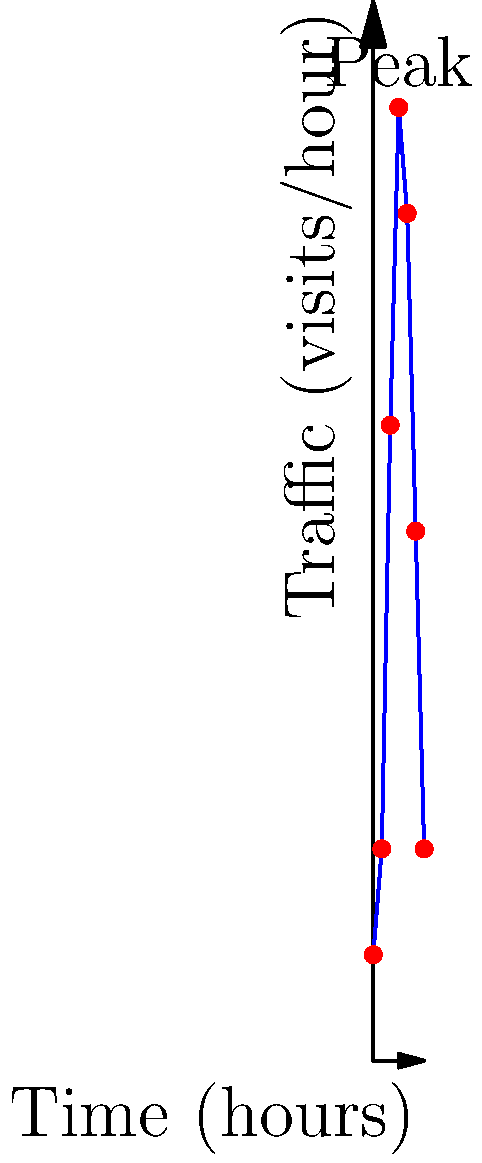As a web developer, you're analyzing your website's traffic data over a 24-hour period. The graph shows the number of visits per hour. If the area under the curve represents the total number of visits for the day, estimate the total daily traffic using the trapezoidal rule with 6 intervals. Round your answer to the nearest hundred. To estimate the area under the curve using the trapezoidal rule:

1. Divide the x-axis into 6 equal intervals of 4 hours each.
2. Use the formula: 
   $$A \approx \frac{h}{2}[f(x_0) + 2f(x_1) + 2f(x_2) + ... + 2f(x_{n-1}) + f(x_n)]$$
   where $h$ is the width of each interval, and $f(x_i)$ are the y-values.

3. In this case:
   $h = 4$ hours
   $f(x_0) = 50$, $f(x_1) = 100$, $f(x_2) = 300$, $f(x_3) = 450$, $f(x_4) = 400$, $f(x_5) = 250$, $f(x_6) = 100$

4. Applying the formula:
   $$A \approx \frac{4}{2}[50 + 2(100) + 2(300) + 2(450) + 2(400) + 2(250) + 100]$$
   $$A \approx 2[50 + 200 + 600 + 900 + 800 + 500 + 100]$$
   $$A \approx 2[3150]$$
   $$A \approx 6300$$

5. Rounding to the nearest hundred: 6300

This represents the estimated total number of visits over the 24-hour period.
Answer: 6300 visits 